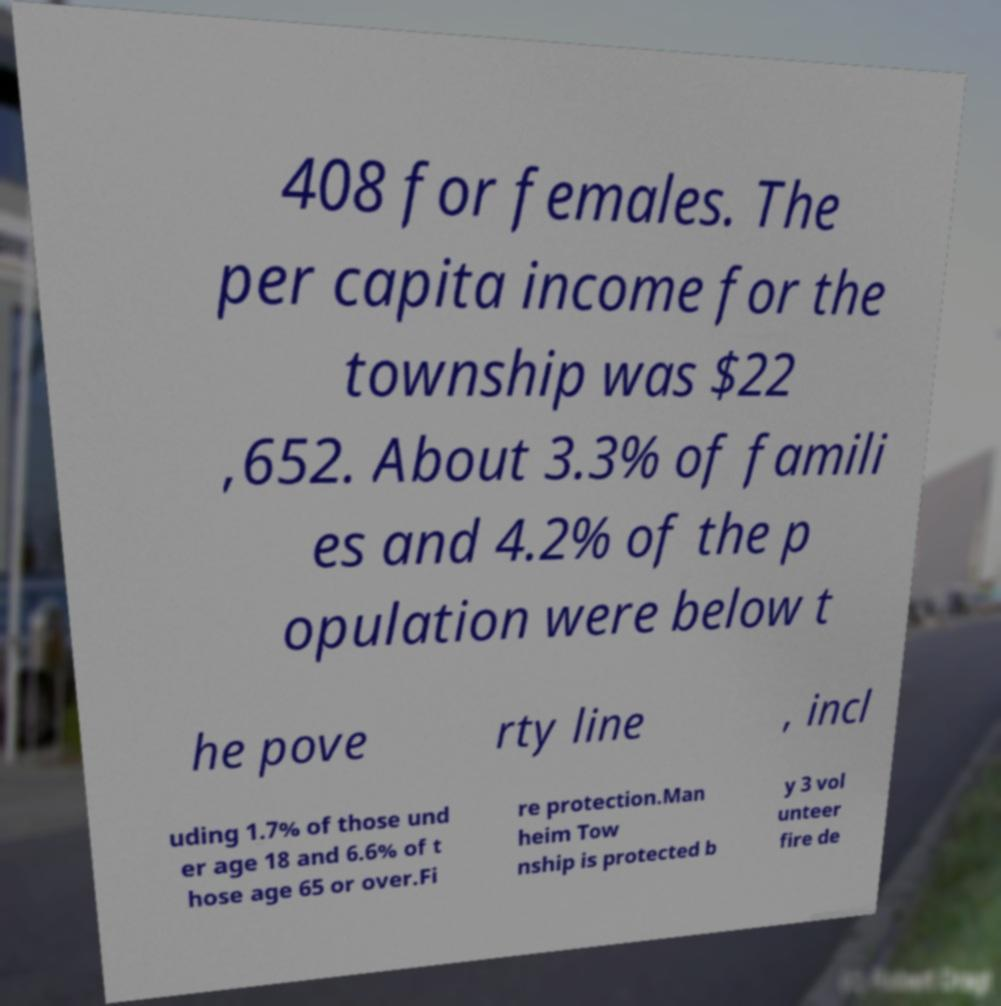Could you assist in decoding the text presented in this image and type it out clearly? 408 for females. The per capita income for the township was $22 ,652. About 3.3% of famili es and 4.2% of the p opulation were below t he pove rty line , incl uding 1.7% of those und er age 18 and 6.6% of t hose age 65 or over.Fi re protection.Man heim Tow nship is protected b y 3 vol unteer fire de 